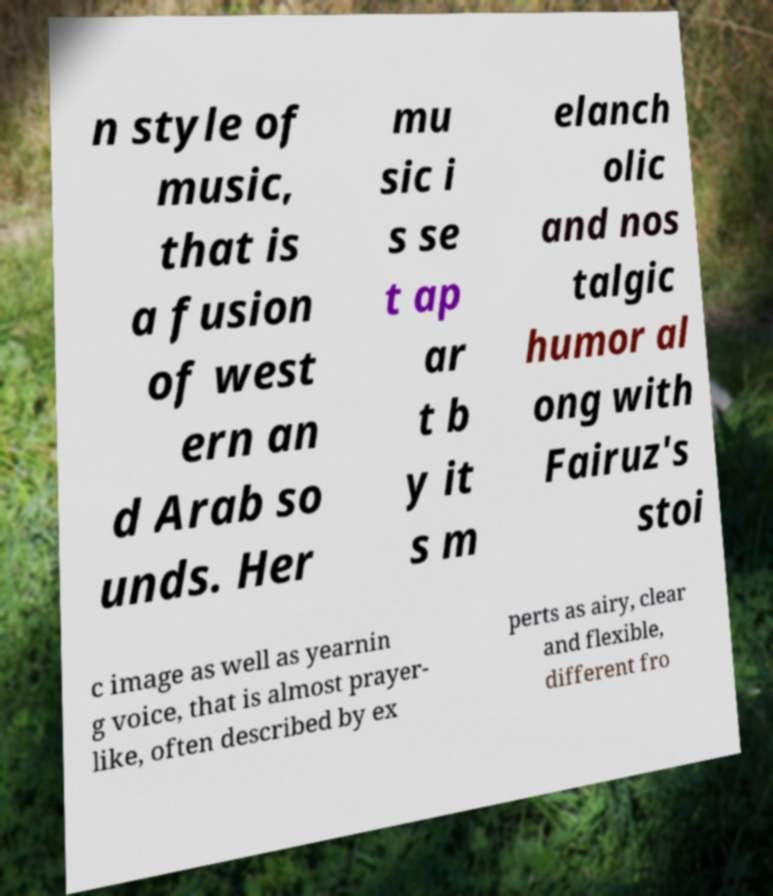What messages or text are displayed in this image? I need them in a readable, typed format. n style of music, that is a fusion of west ern an d Arab so unds. Her mu sic i s se t ap ar t b y it s m elanch olic and nos talgic humor al ong with Fairuz's stoi c image as well as yearnin g voice, that is almost prayer- like, often described by ex perts as airy, clear and flexible, different fro 